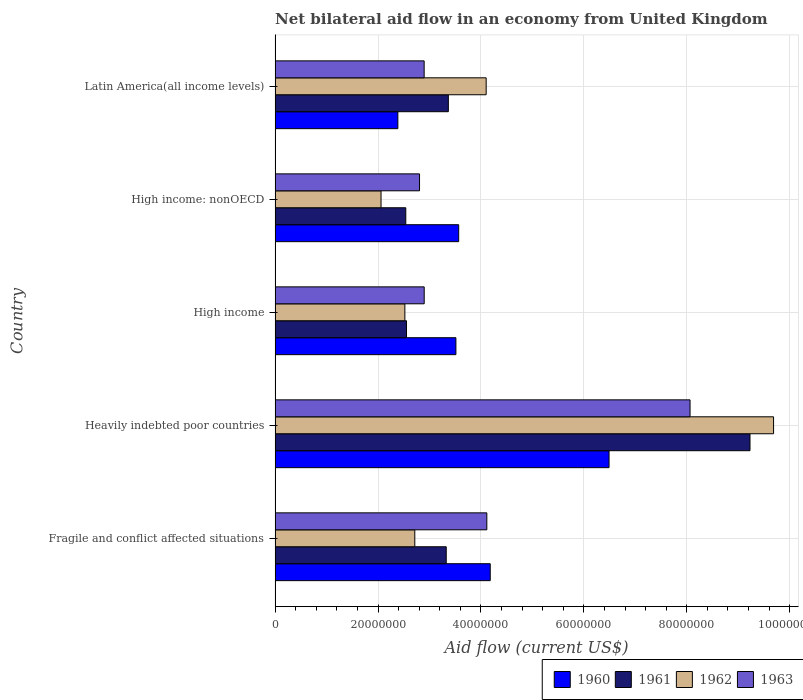How many different coloured bars are there?
Your answer should be compact. 4. How many groups of bars are there?
Provide a succinct answer. 5. Are the number of bars per tick equal to the number of legend labels?
Provide a succinct answer. Yes. What is the net bilateral aid flow in 1960 in Heavily indebted poor countries?
Ensure brevity in your answer.  6.49e+07. Across all countries, what is the maximum net bilateral aid flow in 1961?
Provide a short and direct response. 9.23e+07. Across all countries, what is the minimum net bilateral aid flow in 1961?
Provide a succinct answer. 2.54e+07. In which country was the net bilateral aid flow in 1960 maximum?
Ensure brevity in your answer.  Heavily indebted poor countries. In which country was the net bilateral aid flow in 1961 minimum?
Your response must be concise. High income: nonOECD. What is the total net bilateral aid flow in 1960 in the graph?
Keep it short and to the point. 2.01e+08. What is the difference between the net bilateral aid flow in 1961 in Heavily indebted poor countries and that in High income: nonOECD?
Provide a succinct answer. 6.69e+07. What is the difference between the net bilateral aid flow in 1961 in Latin America(all income levels) and the net bilateral aid flow in 1963 in High income: nonOECD?
Your answer should be very brief. 5.60e+06. What is the average net bilateral aid flow in 1960 per country?
Make the answer very short. 4.03e+07. What is the difference between the net bilateral aid flow in 1961 and net bilateral aid flow in 1962 in High income: nonOECD?
Keep it short and to the point. 4.81e+06. In how many countries, is the net bilateral aid flow in 1960 greater than 12000000 US$?
Your response must be concise. 5. What is the ratio of the net bilateral aid flow in 1961 in High income to that in High income: nonOECD?
Offer a terse response. 1.01. Is the net bilateral aid flow in 1960 in High income: nonOECD less than that in Latin America(all income levels)?
Provide a succinct answer. No. Is the difference between the net bilateral aid flow in 1961 in High income and High income: nonOECD greater than the difference between the net bilateral aid flow in 1962 in High income and High income: nonOECD?
Your answer should be compact. No. What is the difference between the highest and the second highest net bilateral aid flow in 1962?
Offer a terse response. 5.58e+07. What is the difference between the highest and the lowest net bilateral aid flow in 1962?
Your response must be concise. 7.63e+07. In how many countries, is the net bilateral aid flow in 1961 greater than the average net bilateral aid flow in 1961 taken over all countries?
Your answer should be compact. 1. Is it the case that in every country, the sum of the net bilateral aid flow in 1960 and net bilateral aid flow in 1961 is greater than the sum of net bilateral aid flow in 1962 and net bilateral aid flow in 1963?
Make the answer very short. Yes. What does the 2nd bar from the top in High income represents?
Your answer should be very brief. 1962. Is it the case that in every country, the sum of the net bilateral aid flow in 1960 and net bilateral aid flow in 1961 is greater than the net bilateral aid flow in 1963?
Ensure brevity in your answer.  Yes. How many bars are there?
Your response must be concise. 20. What is the difference between two consecutive major ticks on the X-axis?
Provide a short and direct response. 2.00e+07. Does the graph contain any zero values?
Your answer should be very brief. No. Where does the legend appear in the graph?
Ensure brevity in your answer.  Bottom right. How many legend labels are there?
Your response must be concise. 4. How are the legend labels stacked?
Provide a short and direct response. Horizontal. What is the title of the graph?
Provide a short and direct response. Net bilateral aid flow in an economy from United Kingdom. Does "1994" appear as one of the legend labels in the graph?
Offer a terse response. No. What is the label or title of the X-axis?
Keep it short and to the point. Aid flow (current US$). What is the label or title of the Y-axis?
Your response must be concise. Country. What is the Aid flow (current US$) of 1960 in Fragile and conflict affected situations?
Your response must be concise. 4.18e+07. What is the Aid flow (current US$) in 1961 in Fragile and conflict affected situations?
Ensure brevity in your answer.  3.33e+07. What is the Aid flow (current US$) in 1962 in Fragile and conflict affected situations?
Your answer should be compact. 2.72e+07. What is the Aid flow (current US$) of 1963 in Fragile and conflict affected situations?
Provide a short and direct response. 4.12e+07. What is the Aid flow (current US$) of 1960 in Heavily indebted poor countries?
Make the answer very short. 6.49e+07. What is the Aid flow (current US$) of 1961 in Heavily indebted poor countries?
Offer a terse response. 9.23e+07. What is the Aid flow (current US$) in 1962 in Heavily indebted poor countries?
Your answer should be compact. 9.69e+07. What is the Aid flow (current US$) in 1963 in Heavily indebted poor countries?
Keep it short and to the point. 8.06e+07. What is the Aid flow (current US$) in 1960 in High income?
Offer a terse response. 3.51e+07. What is the Aid flow (current US$) of 1961 in High income?
Your response must be concise. 2.55e+07. What is the Aid flow (current US$) of 1962 in High income?
Ensure brevity in your answer.  2.52e+07. What is the Aid flow (current US$) of 1963 in High income?
Make the answer very short. 2.90e+07. What is the Aid flow (current US$) of 1960 in High income: nonOECD?
Ensure brevity in your answer.  3.57e+07. What is the Aid flow (current US$) of 1961 in High income: nonOECD?
Provide a short and direct response. 2.54e+07. What is the Aid flow (current US$) of 1962 in High income: nonOECD?
Your answer should be compact. 2.06e+07. What is the Aid flow (current US$) of 1963 in High income: nonOECD?
Give a very brief answer. 2.81e+07. What is the Aid flow (current US$) of 1960 in Latin America(all income levels)?
Your answer should be compact. 2.39e+07. What is the Aid flow (current US$) in 1961 in Latin America(all income levels)?
Provide a short and direct response. 3.37e+07. What is the Aid flow (current US$) of 1962 in Latin America(all income levels)?
Offer a terse response. 4.10e+07. What is the Aid flow (current US$) of 1963 in Latin America(all income levels)?
Keep it short and to the point. 2.90e+07. Across all countries, what is the maximum Aid flow (current US$) in 1960?
Provide a short and direct response. 6.49e+07. Across all countries, what is the maximum Aid flow (current US$) of 1961?
Provide a short and direct response. 9.23e+07. Across all countries, what is the maximum Aid flow (current US$) in 1962?
Keep it short and to the point. 9.69e+07. Across all countries, what is the maximum Aid flow (current US$) in 1963?
Offer a very short reply. 8.06e+07. Across all countries, what is the minimum Aid flow (current US$) in 1960?
Give a very brief answer. 2.39e+07. Across all countries, what is the minimum Aid flow (current US$) of 1961?
Ensure brevity in your answer.  2.54e+07. Across all countries, what is the minimum Aid flow (current US$) of 1962?
Your answer should be compact. 2.06e+07. Across all countries, what is the minimum Aid flow (current US$) of 1963?
Provide a short and direct response. 2.81e+07. What is the total Aid flow (current US$) in 1960 in the graph?
Your response must be concise. 2.01e+08. What is the total Aid flow (current US$) of 1961 in the graph?
Provide a succinct answer. 2.10e+08. What is the total Aid flow (current US$) in 1962 in the graph?
Provide a short and direct response. 2.11e+08. What is the total Aid flow (current US$) in 1963 in the graph?
Make the answer very short. 2.08e+08. What is the difference between the Aid flow (current US$) in 1960 in Fragile and conflict affected situations and that in Heavily indebted poor countries?
Ensure brevity in your answer.  -2.31e+07. What is the difference between the Aid flow (current US$) in 1961 in Fragile and conflict affected situations and that in Heavily indebted poor countries?
Provide a short and direct response. -5.90e+07. What is the difference between the Aid flow (current US$) of 1962 in Fragile and conflict affected situations and that in Heavily indebted poor countries?
Your answer should be compact. -6.97e+07. What is the difference between the Aid flow (current US$) in 1963 in Fragile and conflict affected situations and that in Heavily indebted poor countries?
Ensure brevity in your answer.  -3.95e+07. What is the difference between the Aid flow (current US$) of 1960 in Fragile and conflict affected situations and that in High income?
Your answer should be very brief. 6.67e+06. What is the difference between the Aid flow (current US$) in 1961 in Fragile and conflict affected situations and that in High income?
Give a very brief answer. 7.72e+06. What is the difference between the Aid flow (current US$) of 1962 in Fragile and conflict affected situations and that in High income?
Your response must be concise. 1.93e+06. What is the difference between the Aid flow (current US$) of 1963 in Fragile and conflict affected situations and that in High income?
Make the answer very short. 1.22e+07. What is the difference between the Aid flow (current US$) of 1960 in Fragile and conflict affected situations and that in High income: nonOECD?
Provide a short and direct response. 6.13e+06. What is the difference between the Aid flow (current US$) in 1961 in Fragile and conflict affected situations and that in High income: nonOECD?
Provide a succinct answer. 7.86e+06. What is the difference between the Aid flow (current US$) of 1962 in Fragile and conflict affected situations and that in High income: nonOECD?
Your answer should be compact. 6.56e+06. What is the difference between the Aid flow (current US$) in 1963 in Fragile and conflict affected situations and that in High income: nonOECD?
Give a very brief answer. 1.31e+07. What is the difference between the Aid flow (current US$) in 1960 in Fragile and conflict affected situations and that in Latin America(all income levels)?
Make the answer very short. 1.80e+07. What is the difference between the Aid flow (current US$) of 1961 in Fragile and conflict affected situations and that in Latin America(all income levels)?
Ensure brevity in your answer.  -4.10e+05. What is the difference between the Aid flow (current US$) of 1962 in Fragile and conflict affected situations and that in Latin America(all income levels)?
Offer a very short reply. -1.39e+07. What is the difference between the Aid flow (current US$) of 1963 in Fragile and conflict affected situations and that in Latin America(all income levels)?
Give a very brief answer. 1.22e+07. What is the difference between the Aid flow (current US$) in 1960 in Heavily indebted poor countries and that in High income?
Provide a short and direct response. 2.98e+07. What is the difference between the Aid flow (current US$) of 1961 in Heavily indebted poor countries and that in High income?
Make the answer very short. 6.68e+07. What is the difference between the Aid flow (current US$) of 1962 in Heavily indebted poor countries and that in High income?
Provide a succinct answer. 7.16e+07. What is the difference between the Aid flow (current US$) of 1963 in Heavily indebted poor countries and that in High income?
Provide a succinct answer. 5.17e+07. What is the difference between the Aid flow (current US$) in 1960 in Heavily indebted poor countries and that in High income: nonOECD?
Keep it short and to the point. 2.92e+07. What is the difference between the Aid flow (current US$) in 1961 in Heavily indebted poor countries and that in High income: nonOECD?
Offer a very short reply. 6.69e+07. What is the difference between the Aid flow (current US$) of 1962 in Heavily indebted poor countries and that in High income: nonOECD?
Provide a succinct answer. 7.63e+07. What is the difference between the Aid flow (current US$) in 1963 in Heavily indebted poor countries and that in High income: nonOECD?
Provide a succinct answer. 5.26e+07. What is the difference between the Aid flow (current US$) of 1960 in Heavily indebted poor countries and that in Latin America(all income levels)?
Provide a succinct answer. 4.10e+07. What is the difference between the Aid flow (current US$) in 1961 in Heavily indebted poor countries and that in Latin America(all income levels)?
Your response must be concise. 5.86e+07. What is the difference between the Aid flow (current US$) of 1962 in Heavily indebted poor countries and that in Latin America(all income levels)?
Make the answer very short. 5.58e+07. What is the difference between the Aid flow (current US$) of 1963 in Heavily indebted poor countries and that in Latin America(all income levels)?
Provide a short and direct response. 5.17e+07. What is the difference between the Aid flow (current US$) in 1960 in High income and that in High income: nonOECD?
Give a very brief answer. -5.40e+05. What is the difference between the Aid flow (current US$) of 1962 in High income and that in High income: nonOECD?
Provide a succinct answer. 4.63e+06. What is the difference between the Aid flow (current US$) of 1963 in High income and that in High income: nonOECD?
Keep it short and to the point. 9.10e+05. What is the difference between the Aid flow (current US$) in 1960 in High income and that in Latin America(all income levels)?
Make the answer very short. 1.13e+07. What is the difference between the Aid flow (current US$) of 1961 in High income and that in Latin America(all income levels)?
Ensure brevity in your answer.  -8.13e+06. What is the difference between the Aid flow (current US$) in 1962 in High income and that in Latin America(all income levels)?
Make the answer very short. -1.58e+07. What is the difference between the Aid flow (current US$) of 1963 in High income and that in Latin America(all income levels)?
Make the answer very short. 10000. What is the difference between the Aid flow (current US$) of 1960 in High income: nonOECD and that in Latin America(all income levels)?
Provide a succinct answer. 1.18e+07. What is the difference between the Aid flow (current US$) of 1961 in High income: nonOECD and that in Latin America(all income levels)?
Your answer should be compact. -8.27e+06. What is the difference between the Aid flow (current US$) of 1962 in High income: nonOECD and that in Latin America(all income levels)?
Your answer should be compact. -2.04e+07. What is the difference between the Aid flow (current US$) in 1963 in High income: nonOECD and that in Latin America(all income levels)?
Keep it short and to the point. -9.00e+05. What is the difference between the Aid flow (current US$) in 1960 in Fragile and conflict affected situations and the Aid flow (current US$) in 1961 in Heavily indebted poor countries?
Keep it short and to the point. -5.05e+07. What is the difference between the Aid flow (current US$) of 1960 in Fragile and conflict affected situations and the Aid flow (current US$) of 1962 in Heavily indebted poor countries?
Offer a very short reply. -5.51e+07. What is the difference between the Aid flow (current US$) in 1960 in Fragile and conflict affected situations and the Aid flow (current US$) in 1963 in Heavily indebted poor countries?
Your response must be concise. -3.88e+07. What is the difference between the Aid flow (current US$) in 1961 in Fragile and conflict affected situations and the Aid flow (current US$) in 1962 in Heavily indebted poor countries?
Make the answer very short. -6.36e+07. What is the difference between the Aid flow (current US$) in 1961 in Fragile and conflict affected situations and the Aid flow (current US$) in 1963 in Heavily indebted poor countries?
Give a very brief answer. -4.74e+07. What is the difference between the Aid flow (current US$) in 1962 in Fragile and conflict affected situations and the Aid flow (current US$) in 1963 in Heavily indebted poor countries?
Your answer should be very brief. -5.35e+07. What is the difference between the Aid flow (current US$) of 1960 in Fragile and conflict affected situations and the Aid flow (current US$) of 1961 in High income?
Offer a very short reply. 1.63e+07. What is the difference between the Aid flow (current US$) in 1960 in Fragile and conflict affected situations and the Aid flow (current US$) in 1962 in High income?
Give a very brief answer. 1.66e+07. What is the difference between the Aid flow (current US$) in 1960 in Fragile and conflict affected situations and the Aid flow (current US$) in 1963 in High income?
Offer a very short reply. 1.28e+07. What is the difference between the Aid flow (current US$) in 1961 in Fragile and conflict affected situations and the Aid flow (current US$) in 1962 in High income?
Keep it short and to the point. 8.04e+06. What is the difference between the Aid flow (current US$) of 1961 in Fragile and conflict affected situations and the Aid flow (current US$) of 1963 in High income?
Offer a terse response. 4.28e+06. What is the difference between the Aid flow (current US$) of 1962 in Fragile and conflict affected situations and the Aid flow (current US$) of 1963 in High income?
Keep it short and to the point. -1.83e+06. What is the difference between the Aid flow (current US$) in 1960 in Fragile and conflict affected situations and the Aid flow (current US$) in 1961 in High income: nonOECD?
Your answer should be compact. 1.64e+07. What is the difference between the Aid flow (current US$) of 1960 in Fragile and conflict affected situations and the Aid flow (current US$) of 1962 in High income: nonOECD?
Offer a terse response. 2.12e+07. What is the difference between the Aid flow (current US$) in 1960 in Fragile and conflict affected situations and the Aid flow (current US$) in 1963 in High income: nonOECD?
Provide a short and direct response. 1.37e+07. What is the difference between the Aid flow (current US$) of 1961 in Fragile and conflict affected situations and the Aid flow (current US$) of 1962 in High income: nonOECD?
Provide a succinct answer. 1.27e+07. What is the difference between the Aid flow (current US$) of 1961 in Fragile and conflict affected situations and the Aid flow (current US$) of 1963 in High income: nonOECD?
Your answer should be compact. 5.19e+06. What is the difference between the Aid flow (current US$) in 1962 in Fragile and conflict affected situations and the Aid flow (current US$) in 1963 in High income: nonOECD?
Give a very brief answer. -9.20e+05. What is the difference between the Aid flow (current US$) of 1960 in Fragile and conflict affected situations and the Aid flow (current US$) of 1961 in Latin America(all income levels)?
Your answer should be compact. 8.14e+06. What is the difference between the Aid flow (current US$) in 1960 in Fragile and conflict affected situations and the Aid flow (current US$) in 1962 in Latin America(all income levels)?
Provide a short and direct response. 7.90e+05. What is the difference between the Aid flow (current US$) in 1960 in Fragile and conflict affected situations and the Aid flow (current US$) in 1963 in Latin America(all income levels)?
Offer a terse response. 1.28e+07. What is the difference between the Aid flow (current US$) of 1961 in Fragile and conflict affected situations and the Aid flow (current US$) of 1962 in Latin America(all income levels)?
Ensure brevity in your answer.  -7.76e+06. What is the difference between the Aid flow (current US$) in 1961 in Fragile and conflict affected situations and the Aid flow (current US$) in 1963 in Latin America(all income levels)?
Offer a very short reply. 4.29e+06. What is the difference between the Aid flow (current US$) of 1962 in Fragile and conflict affected situations and the Aid flow (current US$) of 1963 in Latin America(all income levels)?
Make the answer very short. -1.82e+06. What is the difference between the Aid flow (current US$) of 1960 in Heavily indebted poor countries and the Aid flow (current US$) of 1961 in High income?
Your answer should be very brief. 3.94e+07. What is the difference between the Aid flow (current US$) of 1960 in Heavily indebted poor countries and the Aid flow (current US$) of 1962 in High income?
Ensure brevity in your answer.  3.97e+07. What is the difference between the Aid flow (current US$) in 1960 in Heavily indebted poor countries and the Aid flow (current US$) in 1963 in High income?
Offer a terse response. 3.59e+07. What is the difference between the Aid flow (current US$) in 1961 in Heavily indebted poor countries and the Aid flow (current US$) in 1962 in High income?
Make the answer very short. 6.71e+07. What is the difference between the Aid flow (current US$) in 1961 in Heavily indebted poor countries and the Aid flow (current US$) in 1963 in High income?
Keep it short and to the point. 6.33e+07. What is the difference between the Aid flow (current US$) of 1962 in Heavily indebted poor countries and the Aid flow (current US$) of 1963 in High income?
Your response must be concise. 6.79e+07. What is the difference between the Aid flow (current US$) of 1960 in Heavily indebted poor countries and the Aid flow (current US$) of 1961 in High income: nonOECD?
Make the answer very short. 3.95e+07. What is the difference between the Aid flow (current US$) in 1960 in Heavily indebted poor countries and the Aid flow (current US$) in 1962 in High income: nonOECD?
Ensure brevity in your answer.  4.43e+07. What is the difference between the Aid flow (current US$) in 1960 in Heavily indebted poor countries and the Aid flow (current US$) in 1963 in High income: nonOECD?
Ensure brevity in your answer.  3.68e+07. What is the difference between the Aid flow (current US$) of 1961 in Heavily indebted poor countries and the Aid flow (current US$) of 1962 in High income: nonOECD?
Offer a terse response. 7.17e+07. What is the difference between the Aid flow (current US$) of 1961 in Heavily indebted poor countries and the Aid flow (current US$) of 1963 in High income: nonOECD?
Keep it short and to the point. 6.42e+07. What is the difference between the Aid flow (current US$) of 1962 in Heavily indebted poor countries and the Aid flow (current US$) of 1963 in High income: nonOECD?
Your response must be concise. 6.88e+07. What is the difference between the Aid flow (current US$) of 1960 in Heavily indebted poor countries and the Aid flow (current US$) of 1961 in Latin America(all income levels)?
Your response must be concise. 3.12e+07. What is the difference between the Aid flow (current US$) in 1960 in Heavily indebted poor countries and the Aid flow (current US$) in 1962 in Latin America(all income levels)?
Your answer should be compact. 2.39e+07. What is the difference between the Aid flow (current US$) of 1960 in Heavily indebted poor countries and the Aid flow (current US$) of 1963 in Latin America(all income levels)?
Your answer should be very brief. 3.59e+07. What is the difference between the Aid flow (current US$) in 1961 in Heavily indebted poor countries and the Aid flow (current US$) in 1962 in Latin America(all income levels)?
Give a very brief answer. 5.13e+07. What is the difference between the Aid flow (current US$) of 1961 in Heavily indebted poor countries and the Aid flow (current US$) of 1963 in Latin America(all income levels)?
Provide a succinct answer. 6.33e+07. What is the difference between the Aid flow (current US$) of 1962 in Heavily indebted poor countries and the Aid flow (current US$) of 1963 in Latin America(all income levels)?
Provide a succinct answer. 6.79e+07. What is the difference between the Aid flow (current US$) in 1960 in High income and the Aid flow (current US$) in 1961 in High income: nonOECD?
Ensure brevity in your answer.  9.74e+06. What is the difference between the Aid flow (current US$) of 1960 in High income and the Aid flow (current US$) of 1962 in High income: nonOECD?
Provide a succinct answer. 1.46e+07. What is the difference between the Aid flow (current US$) in 1960 in High income and the Aid flow (current US$) in 1963 in High income: nonOECD?
Your answer should be very brief. 7.07e+06. What is the difference between the Aid flow (current US$) in 1961 in High income and the Aid flow (current US$) in 1962 in High income: nonOECD?
Provide a succinct answer. 4.95e+06. What is the difference between the Aid flow (current US$) in 1961 in High income and the Aid flow (current US$) in 1963 in High income: nonOECD?
Make the answer very short. -2.53e+06. What is the difference between the Aid flow (current US$) of 1962 in High income and the Aid flow (current US$) of 1963 in High income: nonOECD?
Make the answer very short. -2.85e+06. What is the difference between the Aid flow (current US$) in 1960 in High income and the Aid flow (current US$) in 1961 in Latin America(all income levels)?
Your response must be concise. 1.47e+06. What is the difference between the Aid flow (current US$) of 1960 in High income and the Aid flow (current US$) of 1962 in Latin America(all income levels)?
Ensure brevity in your answer.  -5.88e+06. What is the difference between the Aid flow (current US$) of 1960 in High income and the Aid flow (current US$) of 1963 in Latin America(all income levels)?
Your response must be concise. 6.17e+06. What is the difference between the Aid flow (current US$) of 1961 in High income and the Aid flow (current US$) of 1962 in Latin America(all income levels)?
Provide a succinct answer. -1.55e+07. What is the difference between the Aid flow (current US$) of 1961 in High income and the Aid flow (current US$) of 1963 in Latin America(all income levels)?
Your answer should be very brief. -3.43e+06. What is the difference between the Aid flow (current US$) in 1962 in High income and the Aid flow (current US$) in 1963 in Latin America(all income levels)?
Provide a short and direct response. -3.75e+06. What is the difference between the Aid flow (current US$) of 1960 in High income: nonOECD and the Aid flow (current US$) of 1961 in Latin America(all income levels)?
Make the answer very short. 2.01e+06. What is the difference between the Aid flow (current US$) of 1960 in High income: nonOECD and the Aid flow (current US$) of 1962 in Latin America(all income levels)?
Provide a short and direct response. -5.34e+06. What is the difference between the Aid flow (current US$) in 1960 in High income: nonOECD and the Aid flow (current US$) in 1963 in Latin America(all income levels)?
Offer a very short reply. 6.71e+06. What is the difference between the Aid flow (current US$) of 1961 in High income: nonOECD and the Aid flow (current US$) of 1962 in Latin America(all income levels)?
Make the answer very short. -1.56e+07. What is the difference between the Aid flow (current US$) in 1961 in High income: nonOECD and the Aid flow (current US$) in 1963 in Latin America(all income levels)?
Provide a succinct answer. -3.57e+06. What is the difference between the Aid flow (current US$) of 1962 in High income: nonOECD and the Aid flow (current US$) of 1963 in Latin America(all income levels)?
Keep it short and to the point. -8.38e+06. What is the average Aid flow (current US$) of 1960 per country?
Provide a short and direct response. 4.03e+07. What is the average Aid flow (current US$) of 1961 per country?
Your answer should be compact. 4.20e+07. What is the average Aid flow (current US$) of 1962 per country?
Your answer should be very brief. 4.22e+07. What is the average Aid flow (current US$) of 1963 per country?
Ensure brevity in your answer.  4.16e+07. What is the difference between the Aid flow (current US$) of 1960 and Aid flow (current US$) of 1961 in Fragile and conflict affected situations?
Your answer should be very brief. 8.55e+06. What is the difference between the Aid flow (current US$) of 1960 and Aid flow (current US$) of 1962 in Fragile and conflict affected situations?
Keep it short and to the point. 1.47e+07. What is the difference between the Aid flow (current US$) in 1961 and Aid flow (current US$) in 1962 in Fragile and conflict affected situations?
Offer a very short reply. 6.11e+06. What is the difference between the Aid flow (current US$) in 1961 and Aid flow (current US$) in 1963 in Fragile and conflict affected situations?
Provide a short and direct response. -7.89e+06. What is the difference between the Aid flow (current US$) in 1962 and Aid flow (current US$) in 1963 in Fragile and conflict affected situations?
Give a very brief answer. -1.40e+07. What is the difference between the Aid flow (current US$) of 1960 and Aid flow (current US$) of 1961 in Heavily indebted poor countries?
Offer a very short reply. -2.74e+07. What is the difference between the Aid flow (current US$) of 1960 and Aid flow (current US$) of 1962 in Heavily indebted poor countries?
Your answer should be compact. -3.20e+07. What is the difference between the Aid flow (current US$) in 1960 and Aid flow (current US$) in 1963 in Heavily indebted poor countries?
Your answer should be very brief. -1.57e+07. What is the difference between the Aid flow (current US$) of 1961 and Aid flow (current US$) of 1962 in Heavily indebted poor countries?
Keep it short and to the point. -4.58e+06. What is the difference between the Aid flow (current US$) in 1961 and Aid flow (current US$) in 1963 in Heavily indebted poor countries?
Give a very brief answer. 1.16e+07. What is the difference between the Aid flow (current US$) of 1962 and Aid flow (current US$) of 1963 in Heavily indebted poor countries?
Give a very brief answer. 1.62e+07. What is the difference between the Aid flow (current US$) in 1960 and Aid flow (current US$) in 1961 in High income?
Ensure brevity in your answer.  9.60e+06. What is the difference between the Aid flow (current US$) of 1960 and Aid flow (current US$) of 1962 in High income?
Offer a very short reply. 9.92e+06. What is the difference between the Aid flow (current US$) in 1960 and Aid flow (current US$) in 1963 in High income?
Your answer should be compact. 6.16e+06. What is the difference between the Aid flow (current US$) of 1961 and Aid flow (current US$) of 1962 in High income?
Your answer should be compact. 3.20e+05. What is the difference between the Aid flow (current US$) of 1961 and Aid flow (current US$) of 1963 in High income?
Offer a very short reply. -3.44e+06. What is the difference between the Aid flow (current US$) in 1962 and Aid flow (current US$) in 1963 in High income?
Your answer should be very brief. -3.76e+06. What is the difference between the Aid flow (current US$) of 1960 and Aid flow (current US$) of 1961 in High income: nonOECD?
Provide a short and direct response. 1.03e+07. What is the difference between the Aid flow (current US$) in 1960 and Aid flow (current US$) in 1962 in High income: nonOECD?
Make the answer very short. 1.51e+07. What is the difference between the Aid flow (current US$) in 1960 and Aid flow (current US$) in 1963 in High income: nonOECD?
Your answer should be very brief. 7.61e+06. What is the difference between the Aid flow (current US$) of 1961 and Aid flow (current US$) of 1962 in High income: nonOECD?
Provide a succinct answer. 4.81e+06. What is the difference between the Aid flow (current US$) in 1961 and Aid flow (current US$) in 1963 in High income: nonOECD?
Your answer should be very brief. -2.67e+06. What is the difference between the Aid flow (current US$) of 1962 and Aid flow (current US$) of 1963 in High income: nonOECD?
Offer a terse response. -7.48e+06. What is the difference between the Aid flow (current US$) in 1960 and Aid flow (current US$) in 1961 in Latin America(all income levels)?
Keep it short and to the point. -9.81e+06. What is the difference between the Aid flow (current US$) of 1960 and Aid flow (current US$) of 1962 in Latin America(all income levels)?
Your answer should be very brief. -1.72e+07. What is the difference between the Aid flow (current US$) in 1960 and Aid flow (current US$) in 1963 in Latin America(all income levels)?
Keep it short and to the point. -5.11e+06. What is the difference between the Aid flow (current US$) of 1961 and Aid flow (current US$) of 1962 in Latin America(all income levels)?
Offer a terse response. -7.35e+06. What is the difference between the Aid flow (current US$) in 1961 and Aid flow (current US$) in 1963 in Latin America(all income levels)?
Your answer should be compact. 4.70e+06. What is the difference between the Aid flow (current US$) in 1962 and Aid flow (current US$) in 1963 in Latin America(all income levels)?
Keep it short and to the point. 1.20e+07. What is the ratio of the Aid flow (current US$) in 1960 in Fragile and conflict affected situations to that in Heavily indebted poor countries?
Your answer should be compact. 0.64. What is the ratio of the Aid flow (current US$) of 1961 in Fragile and conflict affected situations to that in Heavily indebted poor countries?
Keep it short and to the point. 0.36. What is the ratio of the Aid flow (current US$) in 1962 in Fragile and conflict affected situations to that in Heavily indebted poor countries?
Your answer should be compact. 0.28. What is the ratio of the Aid flow (current US$) of 1963 in Fragile and conflict affected situations to that in Heavily indebted poor countries?
Your answer should be very brief. 0.51. What is the ratio of the Aid flow (current US$) in 1960 in Fragile and conflict affected situations to that in High income?
Offer a very short reply. 1.19. What is the ratio of the Aid flow (current US$) in 1961 in Fragile and conflict affected situations to that in High income?
Keep it short and to the point. 1.3. What is the ratio of the Aid flow (current US$) of 1962 in Fragile and conflict affected situations to that in High income?
Your answer should be very brief. 1.08. What is the ratio of the Aid flow (current US$) in 1963 in Fragile and conflict affected situations to that in High income?
Give a very brief answer. 1.42. What is the ratio of the Aid flow (current US$) of 1960 in Fragile and conflict affected situations to that in High income: nonOECD?
Provide a succinct answer. 1.17. What is the ratio of the Aid flow (current US$) in 1961 in Fragile and conflict affected situations to that in High income: nonOECD?
Give a very brief answer. 1.31. What is the ratio of the Aid flow (current US$) of 1962 in Fragile and conflict affected situations to that in High income: nonOECD?
Your answer should be compact. 1.32. What is the ratio of the Aid flow (current US$) in 1963 in Fragile and conflict affected situations to that in High income: nonOECD?
Offer a terse response. 1.47. What is the ratio of the Aid flow (current US$) in 1960 in Fragile and conflict affected situations to that in Latin America(all income levels)?
Your answer should be compact. 1.75. What is the ratio of the Aid flow (current US$) of 1962 in Fragile and conflict affected situations to that in Latin America(all income levels)?
Your answer should be very brief. 0.66. What is the ratio of the Aid flow (current US$) in 1963 in Fragile and conflict affected situations to that in Latin America(all income levels)?
Make the answer very short. 1.42. What is the ratio of the Aid flow (current US$) of 1960 in Heavily indebted poor countries to that in High income?
Make the answer very short. 1.85. What is the ratio of the Aid flow (current US$) in 1961 in Heavily indebted poor countries to that in High income?
Offer a very short reply. 3.61. What is the ratio of the Aid flow (current US$) of 1962 in Heavily indebted poor countries to that in High income?
Provide a short and direct response. 3.84. What is the ratio of the Aid flow (current US$) in 1963 in Heavily indebted poor countries to that in High income?
Keep it short and to the point. 2.78. What is the ratio of the Aid flow (current US$) of 1960 in Heavily indebted poor countries to that in High income: nonOECD?
Make the answer very short. 1.82. What is the ratio of the Aid flow (current US$) in 1961 in Heavily indebted poor countries to that in High income: nonOECD?
Ensure brevity in your answer.  3.63. What is the ratio of the Aid flow (current US$) of 1962 in Heavily indebted poor countries to that in High income: nonOECD?
Offer a terse response. 4.7. What is the ratio of the Aid flow (current US$) of 1963 in Heavily indebted poor countries to that in High income: nonOECD?
Provide a short and direct response. 2.87. What is the ratio of the Aid flow (current US$) in 1960 in Heavily indebted poor countries to that in Latin America(all income levels)?
Provide a succinct answer. 2.72. What is the ratio of the Aid flow (current US$) in 1961 in Heavily indebted poor countries to that in Latin America(all income levels)?
Keep it short and to the point. 2.74. What is the ratio of the Aid flow (current US$) in 1962 in Heavily indebted poor countries to that in Latin America(all income levels)?
Give a very brief answer. 2.36. What is the ratio of the Aid flow (current US$) in 1963 in Heavily indebted poor countries to that in Latin America(all income levels)?
Give a very brief answer. 2.78. What is the ratio of the Aid flow (current US$) in 1960 in High income to that in High income: nonOECD?
Provide a succinct answer. 0.98. What is the ratio of the Aid flow (current US$) in 1962 in High income to that in High income: nonOECD?
Your response must be concise. 1.22. What is the ratio of the Aid flow (current US$) of 1963 in High income to that in High income: nonOECD?
Give a very brief answer. 1.03. What is the ratio of the Aid flow (current US$) of 1960 in High income to that in Latin America(all income levels)?
Give a very brief answer. 1.47. What is the ratio of the Aid flow (current US$) in 1961 in High income to that in Latin America(all income levels)?
Make the answer very short. 0.76. What is the ratio of the Aid flow (current US$) of 1962 in High income to that in Latin America(all income levels)?
Your answer should be compact. 0.61. What is the ratio of the Aid flow (current US$) in 1963 in High income to that in Latin America(all income levels)?
Keep it short and to the point. 1. What is the ratio of the Aid flow (current US$) of 1960 in High income: nonOECD to that in Latin America(all income levels)?
Provide a short and direct response. 1.5. What is the ratio of the Aid flow (current US$) of 1961 in High income: nonOECD to that in Latin America(all income levels)?
Offer a terse response. 0.75. What is the ratio of the Aid flow (current US$) in 1962 in High income: nonOECD to that in Latin America(all income levels)?
Provide a succinct answer. 0.5. What is the ratio of the Aid flow (current US$) in 1963 in High income: nonOECD to that in Latin America(all income levels)?
Provide a short and direct response. 0.97. What is the difference between the highest and the second highest Aid flow (current US$) of 1960?
Provide a short and direct response. 2.31e+07. What is the difference between the highest and the second highest Aid flow (current US$) of 1961?
Keep it short and to the point. 5.86e+07. What is the difference between the highest and the second highest Aid flow (current US$) of 1962?
Provide a succinct answer. 5.58e+07. What is the difference between the highest and the second highest Aid flow (current US$) of 1963?
Your response must be concise. 3.95e+07. What is the difference between the highest and the lowest Aid flow (current US$) in 1960?
Ensure brevity in your answer.  4.10e+07. What is the difference between the highest and the lowest Aid flow (current US$) of 1961?
Your answer should be compact. 6.69e+07. What is the difference between the highest and the lowest Aid flow (current US$) of 1962?
Provide a succinct answer. 7.63e+07. What is the difference between the highest and the lowest Aid flow (current US$) of 1963?
Make the answer very short. 5.26e+07. 